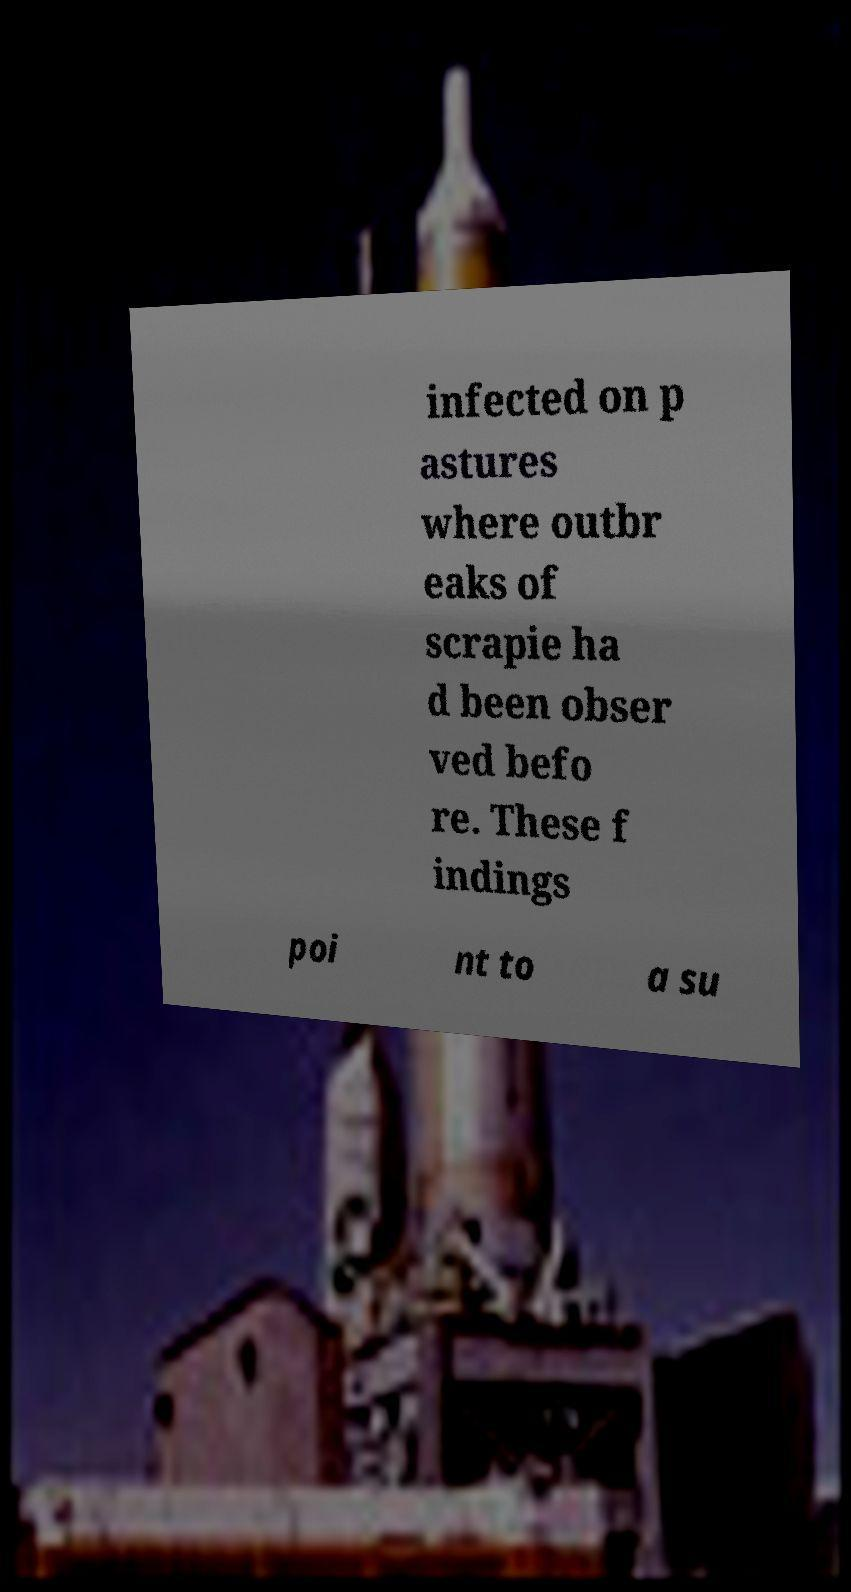For documentation purposes, I need the text within this image transcribed. Could you provide that? infected on p astures where outbr eaks of scrapie ha d been obser ved befo re. These f indings poi nt to a su 